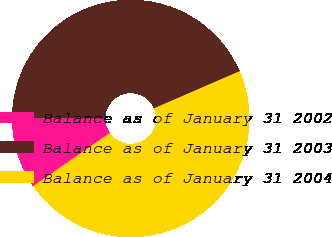Convert chart to OTSL. <chart><loc_0><loc_0><loc_500><loc_500><pie_chart><fcel>Balance as of January 31 2002<fcel>Balance as of January 31 2003<fcel>Balance as of January 31 2004<nl><fcel>9.74%<fcel>43.39%<fcel>46.87%<nl></chart> 